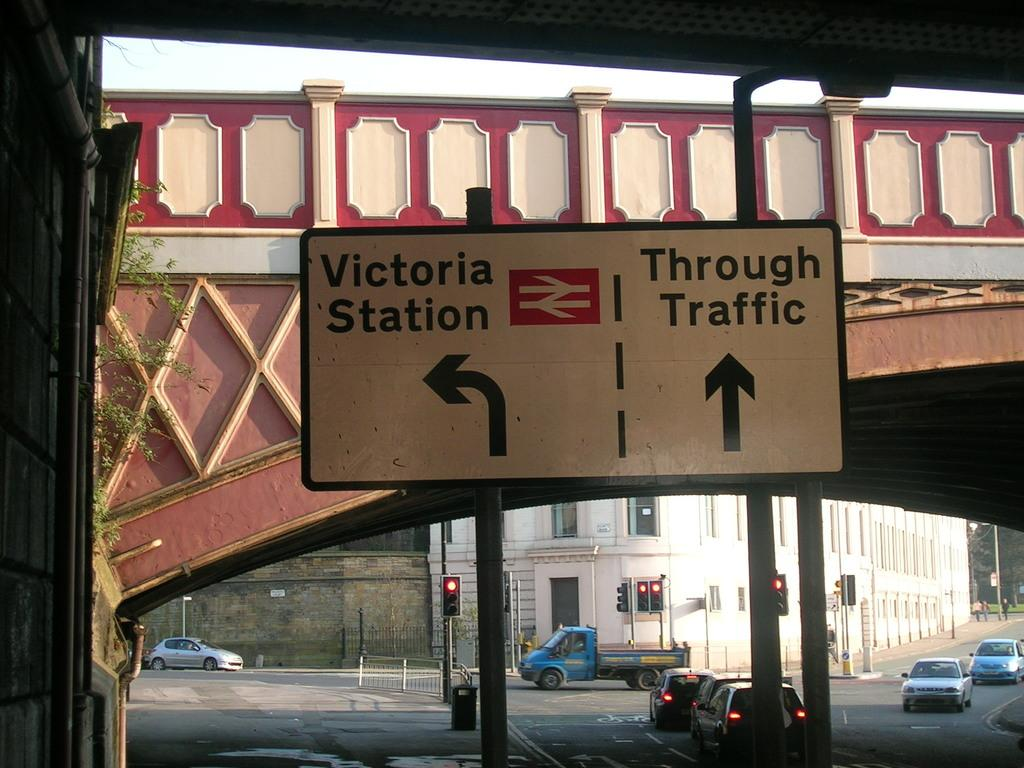Provide a one-sentence caption for the provided image. A street sign explains that Victoria Station is left and Through Traffic is straight ahead. 